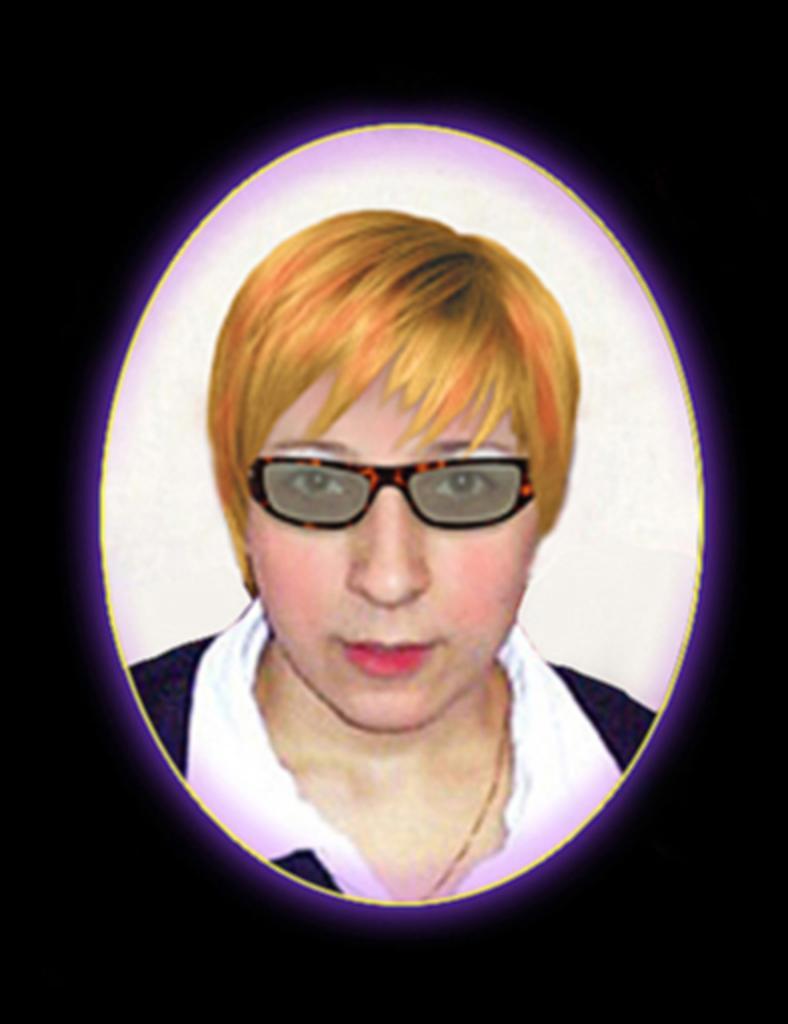Could you give a brief overview of what you see in this image? In this image, we can see a lady wearing glasses. 